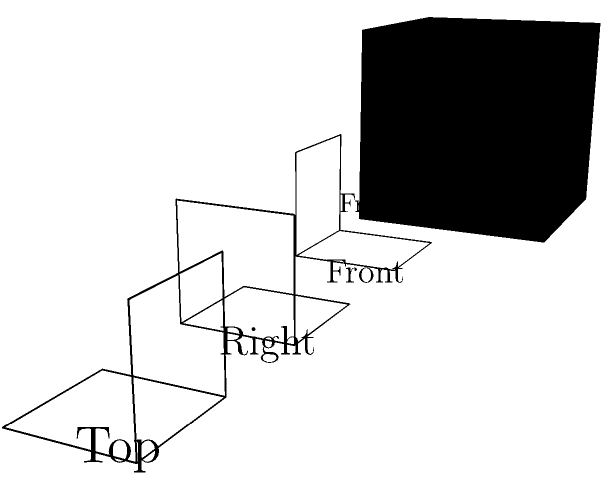As a leader overseeing operations, you need to optimize space utilization in your center. Given the 3D structure shown above and its corresponding front, right, and top views, determine the total number of cubes in the structure. How would this inform your decision-making process for space management? To determine the number of cubes in the 3D structure, we'll analyze each view and combine the information:

1. Front view: Shows a 2x2 grid of cubes
2. Right view: Shows a 2x2 grid of cubes
3. Top view: Shows a 2x2 grid of cubes, with one cube missing in the back-right corner

Step 1: The maximum possible number of cubes based on the front and right views is 2 x 2 x 2 = 8 cubes.

Step 2: The top view reveals that one cube is missing from the back-right corner.

Step 3: Therefore, the total number of cubes is 8 - 1 = 7 cubes.

This information can inform space management decisions by:
1. Providing accurate volume calculations for storage or activity areas
2. Helping to plan efficient layouts for different program needs
3. Allowing for precise resource allocation based on available space
4. Facilitating clear communication about space utilization to staff and stakeholders
Answer: 7 cubes 